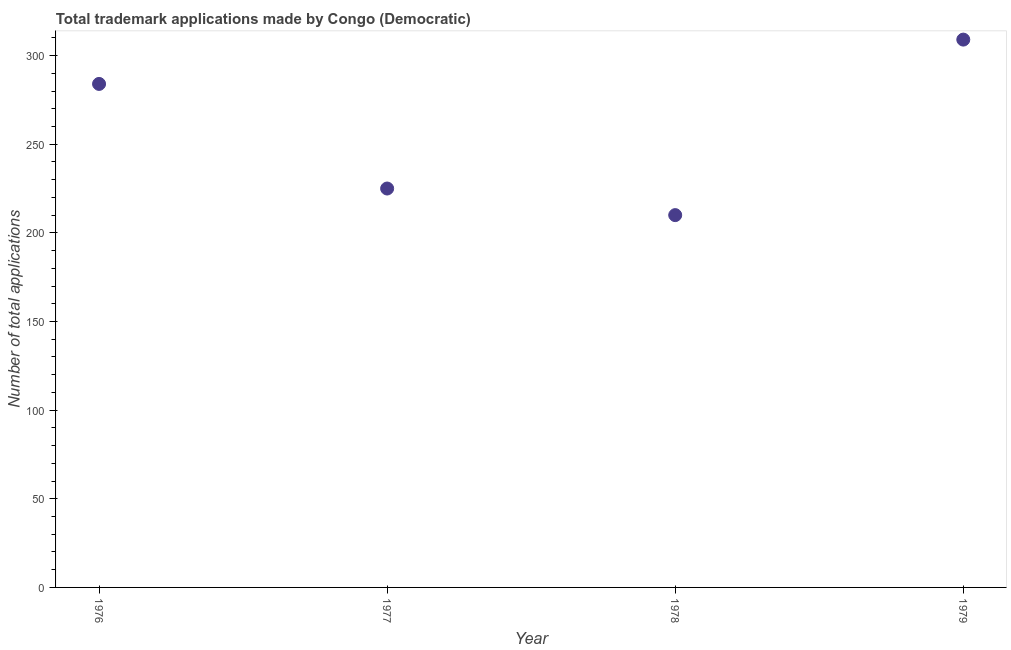What is the number of trademark applications in 1977?
Your answer should be very brief. 225. Across all years, what is the maximum number of trademark applications?
Your answer should be very brief. 309. Across all years, what is the minimum number of trademark applications?
Your response must be concise. 210. In which year was the number of trademark applications maximum?
Give a very brief answer. 1979. In which year was the number of trademark applications minimum?
Make the answer very short. 1978. What is the sum of the number of trademark applications?
Provide a short and direct response. 1028. What is the difference between the number of trademark applications in 1977 and 1978?
Keep it short and to the point. 15. What is the average number of trademark applications per year?
Offer a terse response. 257. What is the median number of trademark applications?
Keep it short and to the point. 254.5. In how many years, is the number of trademark applications greater than 190 ?
Your response must be concise. 4. What is the ratio of the number of trademark applications in 1977 to that in 1979?
Offer a very short reply. 0.73. Is the difference between the number of trademark applications in 1977 and 1978 greater than the difference between any two years?
Your response must be concise. No. What is the difference between the highest and the lowest number of trademark applications?
Your answer should be compact. 99. How many years are there in the graph?
Offer a terse response. 4. What is the difference between two consecutive major ticks on the Y-axis?
Give a very brief answer. 50. Are the values on the major ticks of Y-axis written in scientific E-notation?
Keep it short and to the point. No. Does the graph contain grids?
Offer a very short reply. No. What is the title of the graph?
Your answer should be compact. Total trademark applications made by Congo (Democratic). What is the label or title of the X-axis?
Ensure brevity in your answer.  Year. What is the label or title of the Y-axis?
Provide a short and direct response. Number of total applications. What is the Number of total applications in 1976?
Your response must be concise. 284. What is the Number of total applications in 1977?
Keep it short and to the point. 225. What is the Number of total applications in 1978?
Your answer should be compact. 210. What is the Number of total applications in 1979?
Keep it short and to the point. 309. What is the difference between the Number of total applications in 1976 and 1979?
Ensure brevity in your answer.  -25. What is the difference between the Number of total applications in 1977 and 1979?
Provide a short and direct response. -84. What is the difference between the Number of total applications in 1978 and 1979?
Offer a terse response. -99. What is the ratio of the Number of total applications in 1976 to that in 1977?
Offer a terse response. 1.26. What is the ratio of the Number of total applications in 1976 to that in 1978?
Make the answer very short. 1.35. What is the ratio of the Number of total applications in 1976 to that in 1979?
Offer a very short reply. 0.92. What is the ratio of the Number of total applications in 1977 to that in 1978?
Your answer should be compact. 1.07. What is the ratio of the Number of total applications in 1977 to that in 1979?
Provide a short and direct response. 0.73. What is the ratio of the Number of total applications in 1978 to that in 1979?
Your answer should be very brief. 0.68. 